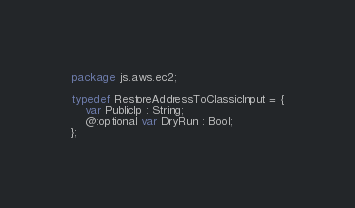Convert code to text. <code><loc_0><loc_0><loc_500><loc_500><_Haxe_>package js.aws.ec2;

typedef RestoreAddressToClassicInput = {
    var PublicIp : String;
    @:optional var DryRun : Bool;
};
</code> 